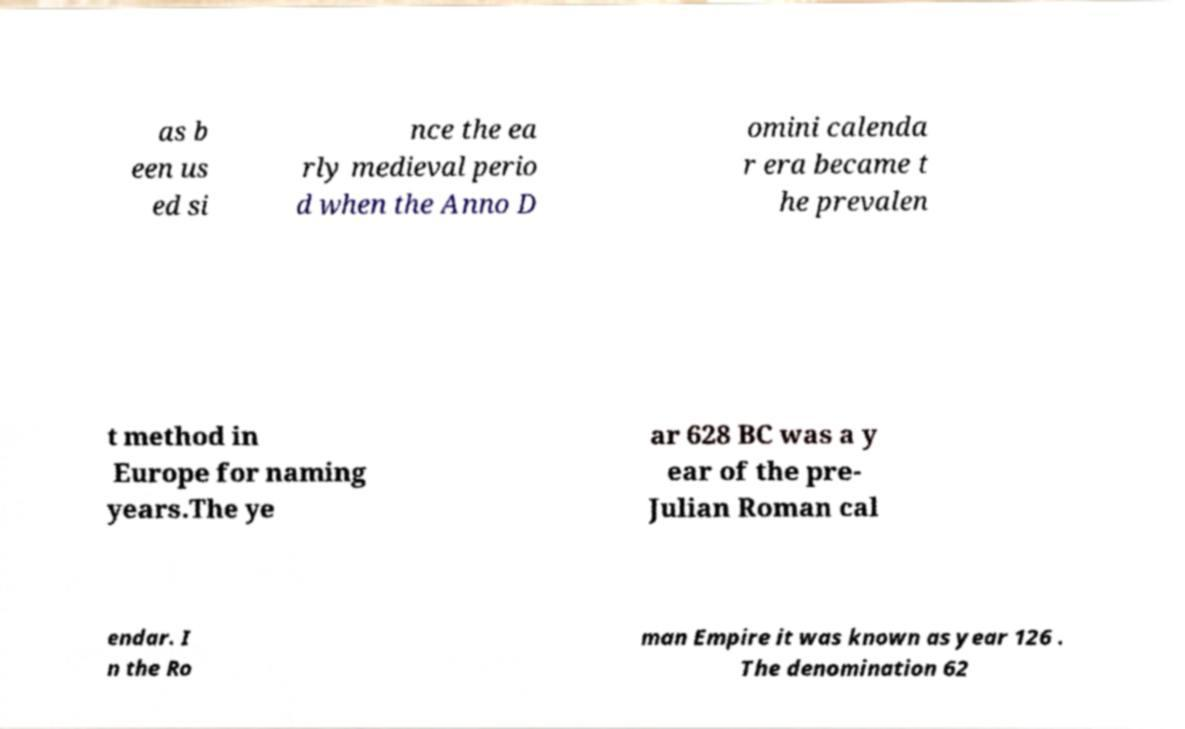Can you read and provide the text displayed in the image?This photo seems to have some interesting text. Can you extract and type it out for me? as b een us ed si nce the ea rly medieval perio d when the Anno D omini calenda r era became t he prevalen t method in Europe for naming years.The ye ar 628 BC was a y ear of the pre- Julian Roman cal endar. I n the Ro man Empire it was known as year 126 . The denomination 62 